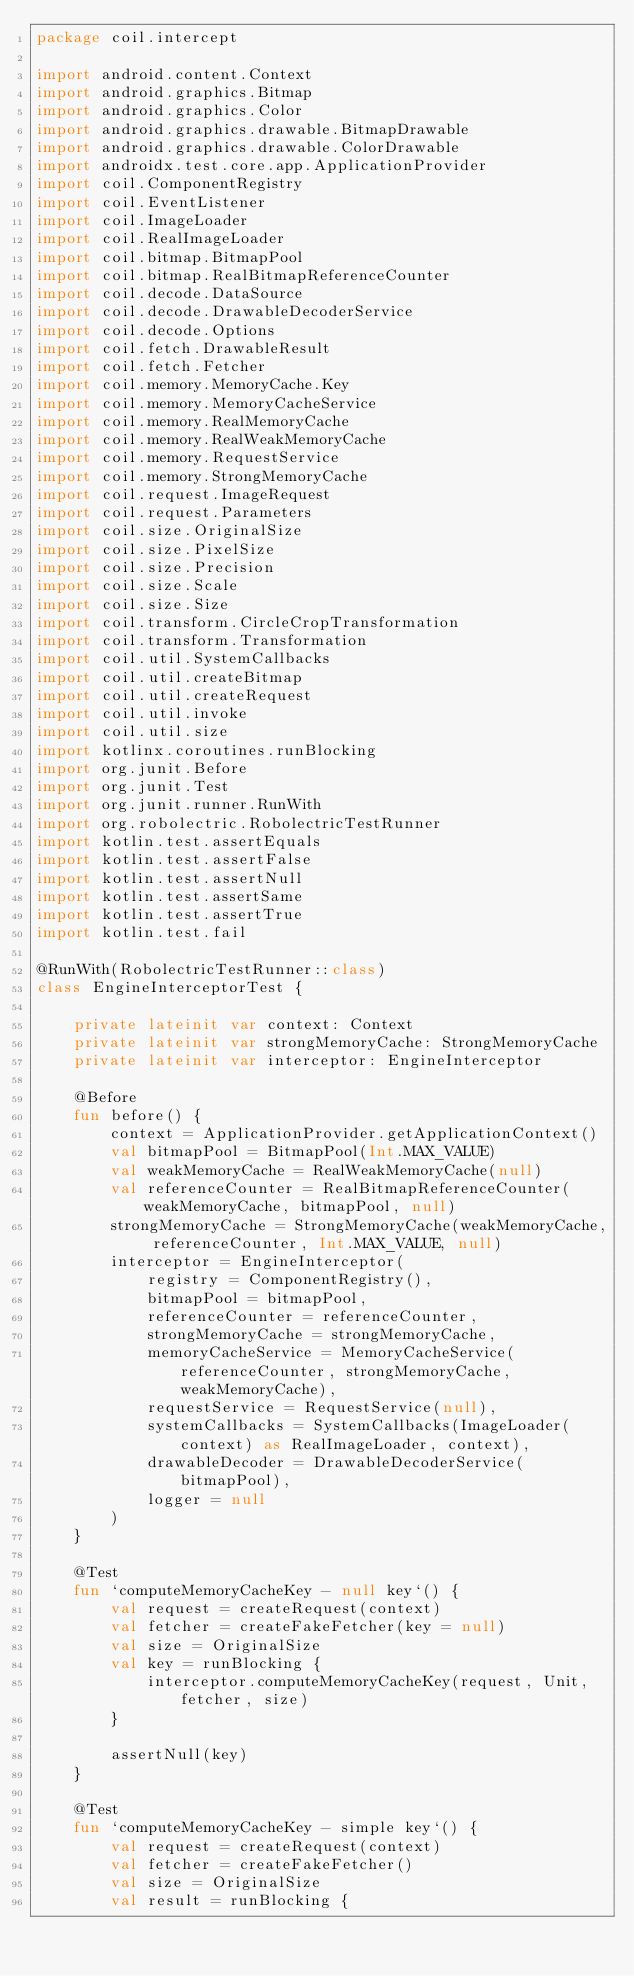Convert code to text. <code><loc_0><loc_0><loc_500><loc_500><_Kotlin_>package coil.intercept

import android.content.Context
import android.graphics.Bitmap
import android.graphics.Color
import android.graphics.drawable.BitmapDrawable
import android.graphics.drawable.ColorDrawable
import androidx.test.core.app.ApplicationProvider
import coil.ComponentRegistry
import coil.EventListener
import coil.ImageLoader
import coil.RealImageLoader
import coil.bitmap.BitmapPool
import coil.bitmap.RealBitmapReferenceCounter
import coil.decode.DataSource
import coil.decode.DrawableDecoderService
import coil.decode.Options
import coil.fetch.DrawableResult
import coil.fetch.Fetcher
import coil.memory.MemoryCache.Key
import coil.memory.MemoryCacheService
import coil.memory.RealMemoryCache
import coil.memory.RealWeakMemoryCache
import coil.memory.RequestService
import coil.memory.StrongMemoryCache
import coil.request.ImageRequest
import coil.request.Parameters
import coil.size.OriginalSize
import coil.size.PixelSize
import coil.size.Precision
import coil.size.Scale
import coil.size.Size
import coil.transform.CircleCropTransformation
import coil.transform.Transformation
import coil.util.SystemCallbacks
import coil.util.createBitmap
import coil.util.createRequest
import coil.util.invoke
import coil.util.size
import kotlinx.coroutines.runBlocking
import org.junit.Before
import org.junit.Test
import org.junit.runner.RunWith
import org.robolectric.RobolectricTestRunner
import kotlin.test.assertEquals
import kotlin.test.assertFalse
import kotlin.test.assertNull
import kotlin.test.assertSame
import kotlin.test.assertTrue
import kotlin.test.fail

@RunWith(RobolectricTestRunner::class)
class EngineInterceptorTest {

    private lateinit var context: Context
    private lateinit var strongMemoryCache: StrongMemoryCache
    private lateinit var interceptor: EngineInterceptor

    @Before
    fun before() {
        context = ApplicationProvider.getApplicationContext()
        val bitmapPool = BitmapPool(Int.MAX_VALUE)
        val weakMemoryCache = RealWeakMemoryCache(null)
        val referenceCounter = RealBitmapReferenceCounter(weakMemoryCache, bitmapPool, null)
        strongMemoryCache = StrongMemoryCache(weakMemoryCache, referenceCounter, Int.MAX_VALUE, null)
        interceptor = EngineInterceptor(
            registry = ComponentRegistry(),
            bitmapPool = bitmapPool,
            referenceCounter = referenceCounter,
            strongMemoryCache = strongMemoryCache,
            memoryCacheService = MemoryCacheService(referenceCounter, strongMemoryCache, weakMemoryCache),
            requestService = RequestService(null),
            systemCallbacks = SystemCallbacks(ImageLoader(context) as RealImageLoader, context),
            drawableDecoder = DrawableDecoderService(bitmapPool),
            logger = null
        )
    }

    @Test
    fun `computeMemoryCacheKey - null key`() {
        val request = createRequest(context)
        val fetcher = createFakeFetcher(key = null)
        val size = OriginalSize
        val key = runBlocking {
            interceptor.computeMemoryCacheKey(request, Unit, fetcher, size)
        }

        assertNull(key)
    }

    @Test
    fun `computeMemoryCacheKey - simple key`() {
        val request = createRequest(context)
        val fetcher = createFakeFetcher()
        val size = OriginalSize
        val result = runBlocking {</code> 